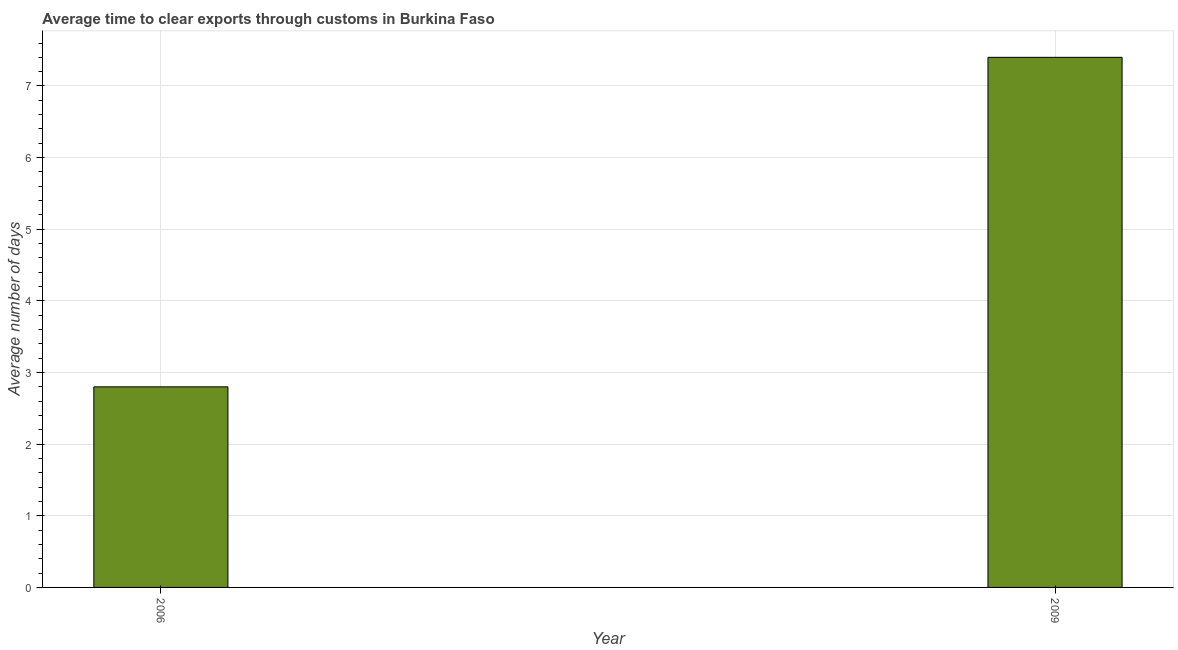Does the graph contain any zero values?
Provide a succinct answer. No. Does the graph contain grids?
Provide a succinct answer. Yes. What is the title of the graph?
Your answer should be compact. Average time to clear exports through customs in Burkina Faso. What is the label or title of the Y-axis?
Provide a short and direct response. Average number of days. What is the time to clear exports through customs in 2009?
Keep it short and to the point. 7.4. Across all years, what is the maximum time to clear exports through customs?
Provide a succinct answer. 7.4. Across all years, what is the minimum time to clear exports through customs?
Ensure brevity in your answer.  2.8. In which year was the time to clear exports through customs maximum?
Provide a short and direct response. 2009. What is the difference between the time to clear exports through customs in 2006 and 2009?
Give a very brief answer. -4.6. What is the median time to clear exports through customs?
Give a very brief answer. 5.1. What is the ratio of the time to clear exports through customs in 2006 to that in 2009?
Make the answer very short. 0.38. How many bars are there?
Provide a succinct answer. 2. Are all the bars in the graph horizontal?
Provide a succinct answer. No. What is the Average number of days in 2009?
Provide a short and direct response. 7.4. What is the difference between the Average number of days in 2006 and 2009?
Provide a short and direct response. -4.6. What is the ratio of the Average number of days in 2006 to that in 2009?
Your answer should be compact. 0.38. 